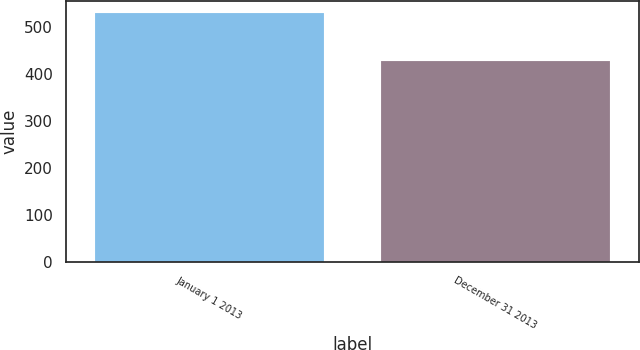<chart> <loc_0><loc_0><loc_500><loc_500><bar_chart><fcel>January 1 2013<fcel>December 31 2013<nl><fcel>530.5<fcel>427.9<nl></chart> 